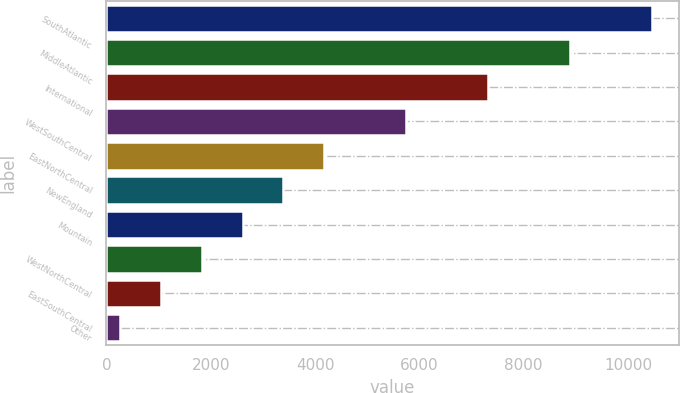Convert chart. <chart><loc_0><loc_0><loc_500><loc_500><bar_chart><fcel>SouthAtlantic<fcel>MiddleAtlantic<fcel>International<fcel>WestSouthCentral<fcel>EastNorthCentral<fcel>NewEngland<fcel>Mountain<fcel>WestNorthCentral<fcel>EastSouthCentral<fcel>Other<nl><fcel>10454.5<fcel>8885.5<fcel>7316.5<fcel>5747.5<fcel>4178.5<fcel>3394<fcel>2609.5<fcel>1825<fcel>1040.5<fcel>256<nl></chart> 